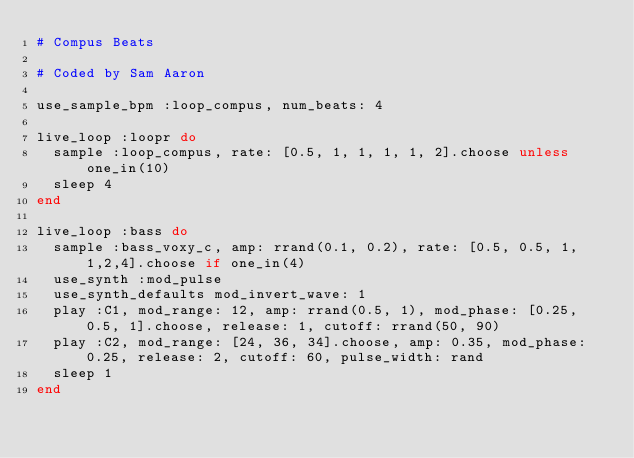Convert code to text. <code><loc_0><loc_0><loc_500><loc_500><_Ruby_># Compus Beats

# Coded by Sam Aaron

use_sample_bpm :loop_compus, num_beats: 4

live_loop :loopr do
  sample :loop_compus, rate: [0.5, 1, 1, 1, 1, 2].choose unless one_in(10)
  sleep 4
end

live_loop :bass do
  sample :bass_voxy_c, amp: rrand(0.1, 0.2), rate: [0.5, 0.5, 1, 1,2,4].choose if one_in(4)
  use_synth :mod_pulse
  use_synth_defaults mod_invert_wave: 1
  play :C1, mod_range: 12, amp: rrand(0.5, 1), mod_phase: [0.25, 0.5, 1].choose, release: 1, cutoff: rrand(50, 90)
  play :C2, mod_range: [24, 36, 34].choose, amp: 0.35, mod_phase: 0.25, release: 2, cutoff: 60, pulse_width: rand
  sleep 1
end

</code> 